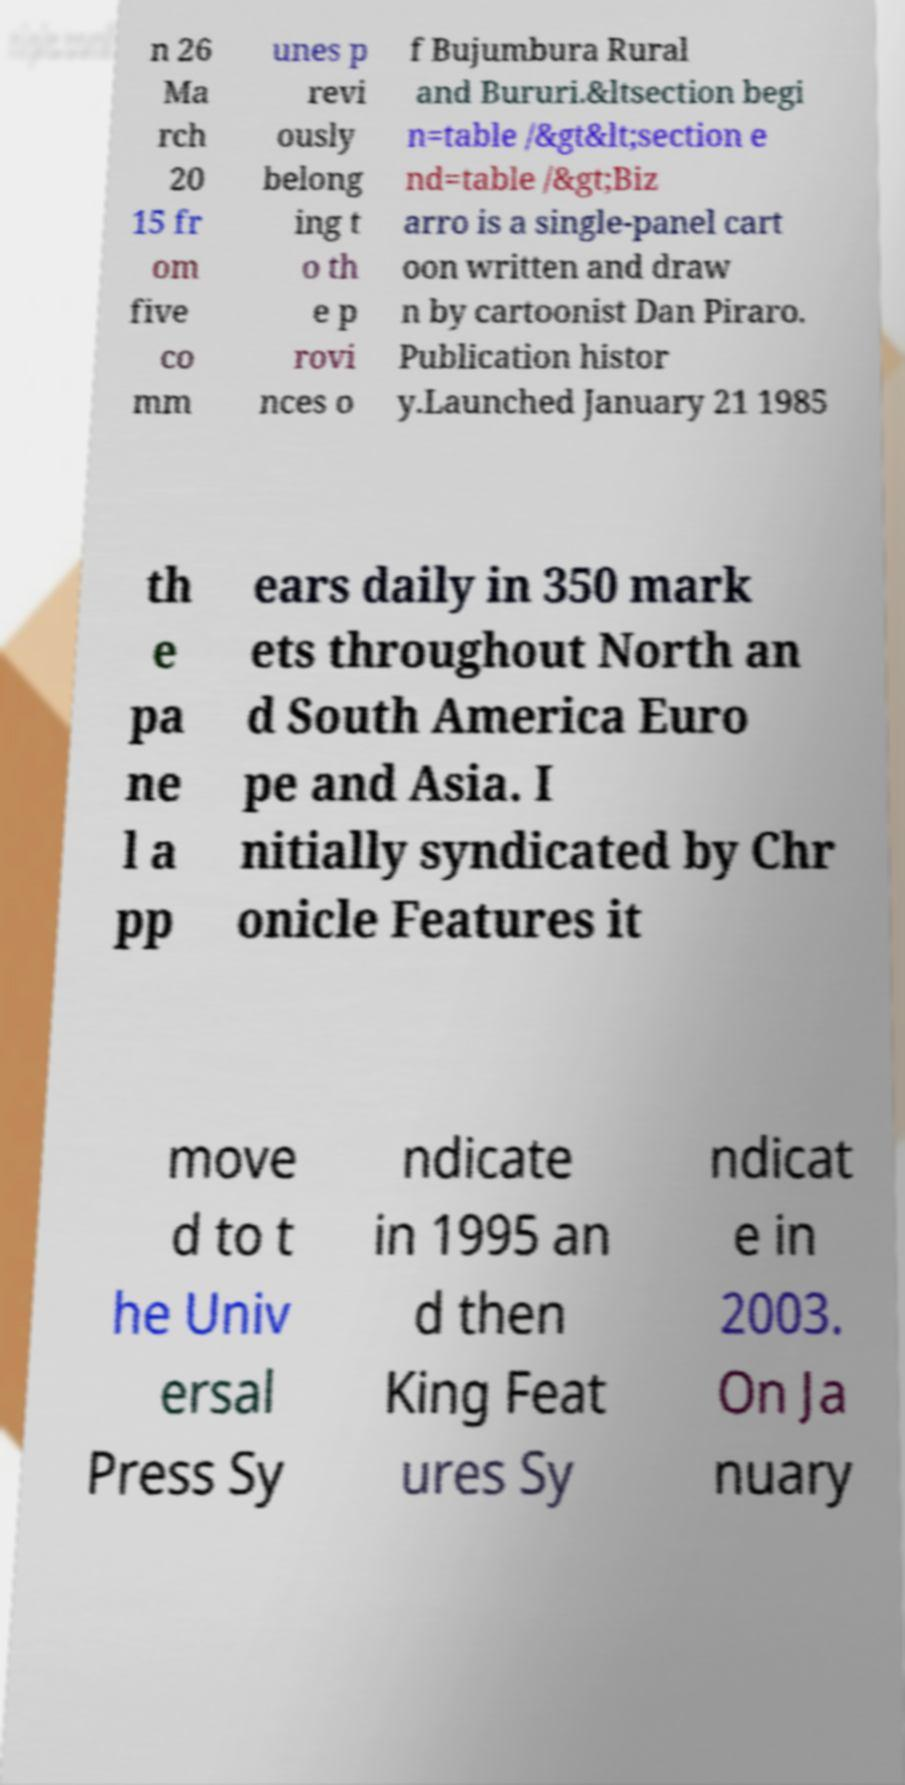Could you assist in decoding the text presented in this image and type it out clearly? n 26 Ma rch 20 15 fr om five co mm unes p revi ously belong ing t o th e p rovi nces o f Bujumbura Rural and Bururi.&ltsection begi n=table /&gt&lt;section e nd=table /&gt;Biz arro is a single-panel cart oon written and draw n by cartoonist Dan Piraro. Publication histor y.Launched January 21 1985 th e pa ne l a pp ears daily in 350 mark ets throughout North an d South America Euro pe and Asia. I nitially syndicated by Chr onicle Features it move d to t he Univ ersal Press Sy ndicate in 1995 an d then King Feat ures Sy ndicat e in 2003. On Ja nuary 